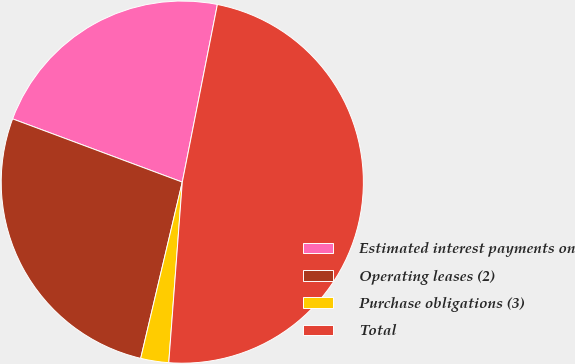Convert chart. <chart><loc_0><loc_0><loc_500><loc_500><pie_chart><fcel>Estimated interest payments on<fcel>Operating leases (2)<fcel>Purchase obligations (3)<fcel>Total<nl><fcel>22.43%<fcel>26.99%<fcel>2.5%<fcel>48.09%<nl></chart> 